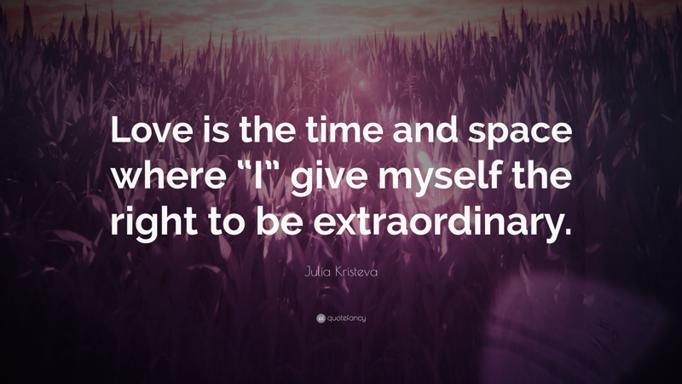How does the visual design of the image enhance the meaning of the quote? The visual design uses a blurred and ethereal backdrop that emphasizes a sense of transcendence and the extraordinary. By placing the text of Julia Kristeva’s quote over this whimsical landscape, it metaphorically represents the boundless potential and majesty of love. The choice of a warm color palette further enhances feelings of passion and wonder, perfectly encapsulating the theme of extraordinary personal transformation through love. What emotions do you think this image is intended to evoke in the viewer? The combination of the inspiring quote and the enchanting visual elements likely aims to evoke feelings of hope, inspiration, and introspection. The image prompts the viewer to ponder their own experiences with love and how it has enabled them to transcend ordinary bounds, inviting a personal connection with the theme of being extraordinary. 